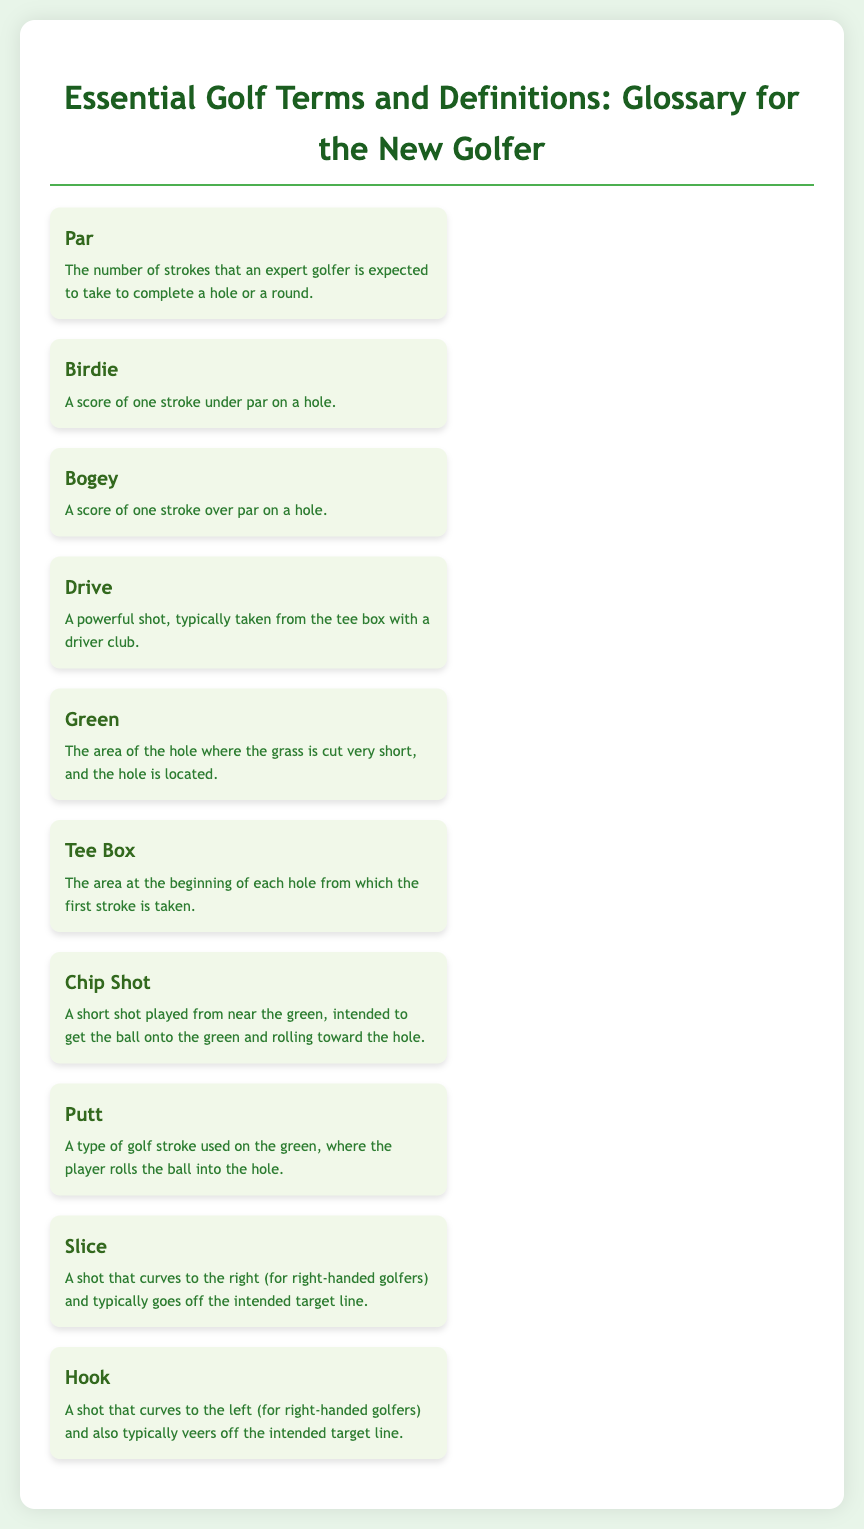What is a Birdie? A Birdie is defined in the document as a score of one stroke under par on a hole.
Answer: One stroke under par What area is referred to as the Green? The Green is defined as the area of the hole where the grass is cut very short, and the hole is located.
Answer: Area with short grass What does a Bogey mean? A Bogey is defined as a score of one stroke over par on a hole in the document.
Answer: One stroke over par What is a Drive in golf? A Drive is described as a powerful shot, typically taken from the tee box with a driver club.
Answer: Powerful shot What type of shot is a Putt? A Putt is defined as a type of golf stroke used on the green, where the player rolls the ball into the hole.
Answer: Roll the ball into the hole What is the purpose of a Chip Shot? A Chip Shot is intended to get the ball onto the green and rolling toward the hole, as stated in the document.
Answer: Get ball onto green Which term describes a shot that curves to the right? The document describes a shot that curves to the right as a Slice.
Answer: Slice How is the Tee Box defined? The Tee Box is defined as the area at the beginning of each hole from which the first stroke is taken.
Answer: Area for first stroke What does the term "Par" refer to? The term Par refers to the number of strokes that an expert golfer is expected to take to complete a hole or a round, according to the document.
Answer: Expected strokes to complete 